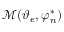<formula> <loc_0><loc_0><loc_500><loc_500>\mathcal { M } ( \vartheta _ { e } , \varphi _ { n } ^ { * } )</formula> 